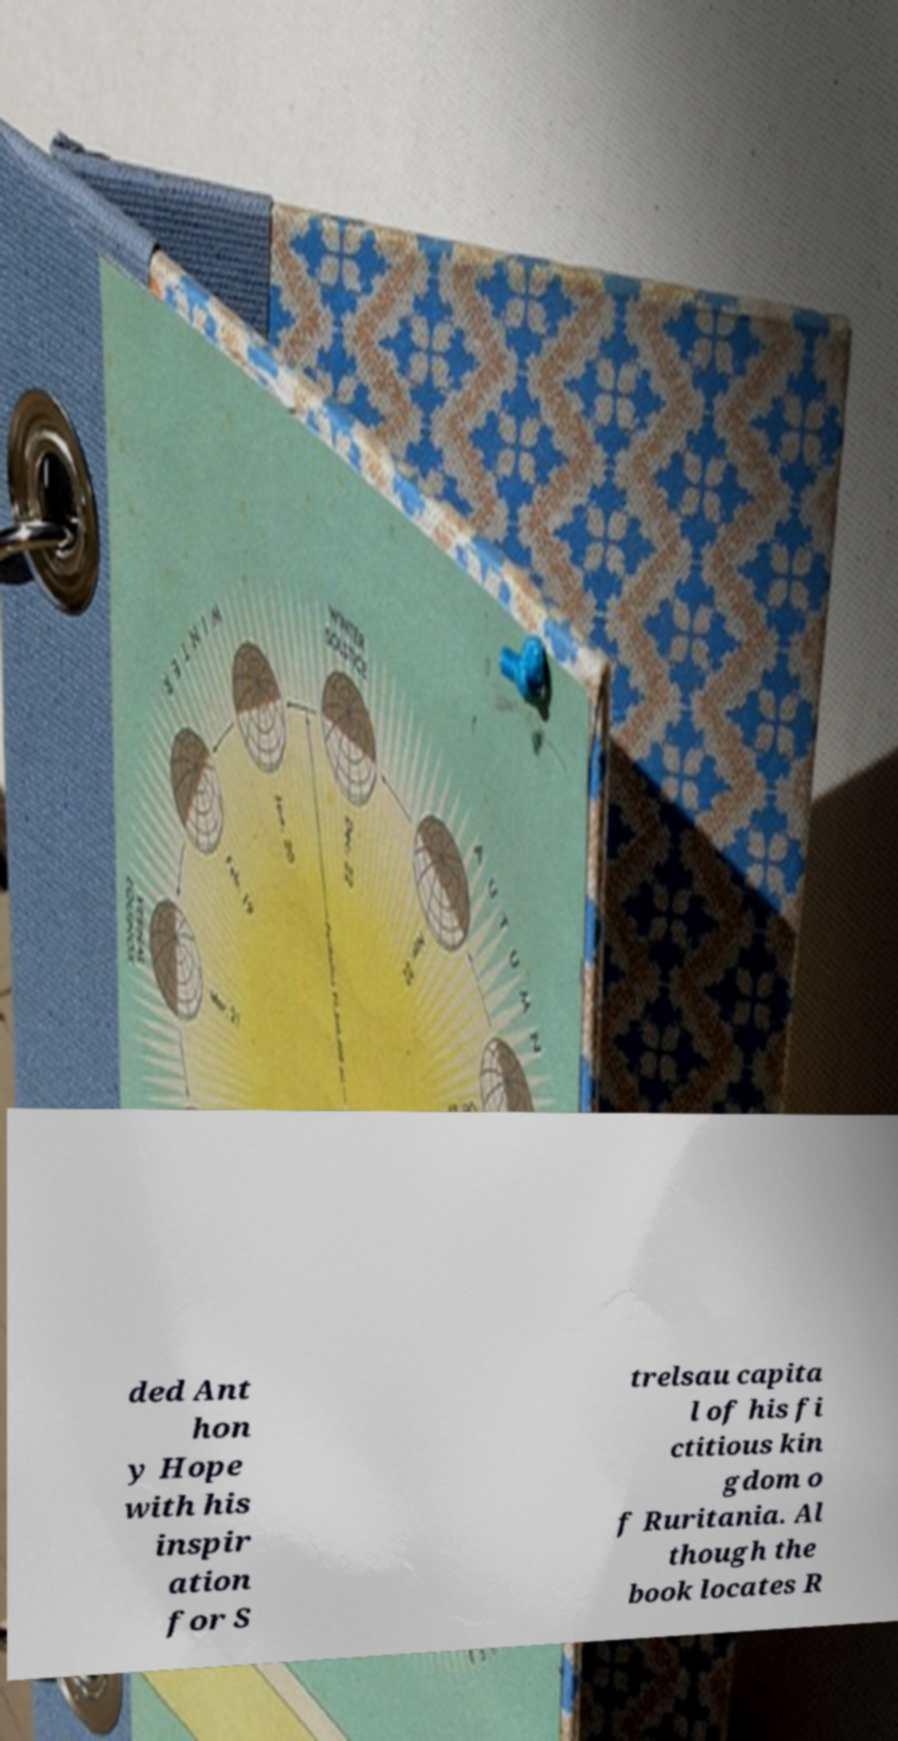Please read and relay the text visible in this image. What does it say? ded Ant hon y Hope with his inspir ation for S trelsau capita l of his fi ctitious kin gdom o f Ruritania. Al though the book locates R 